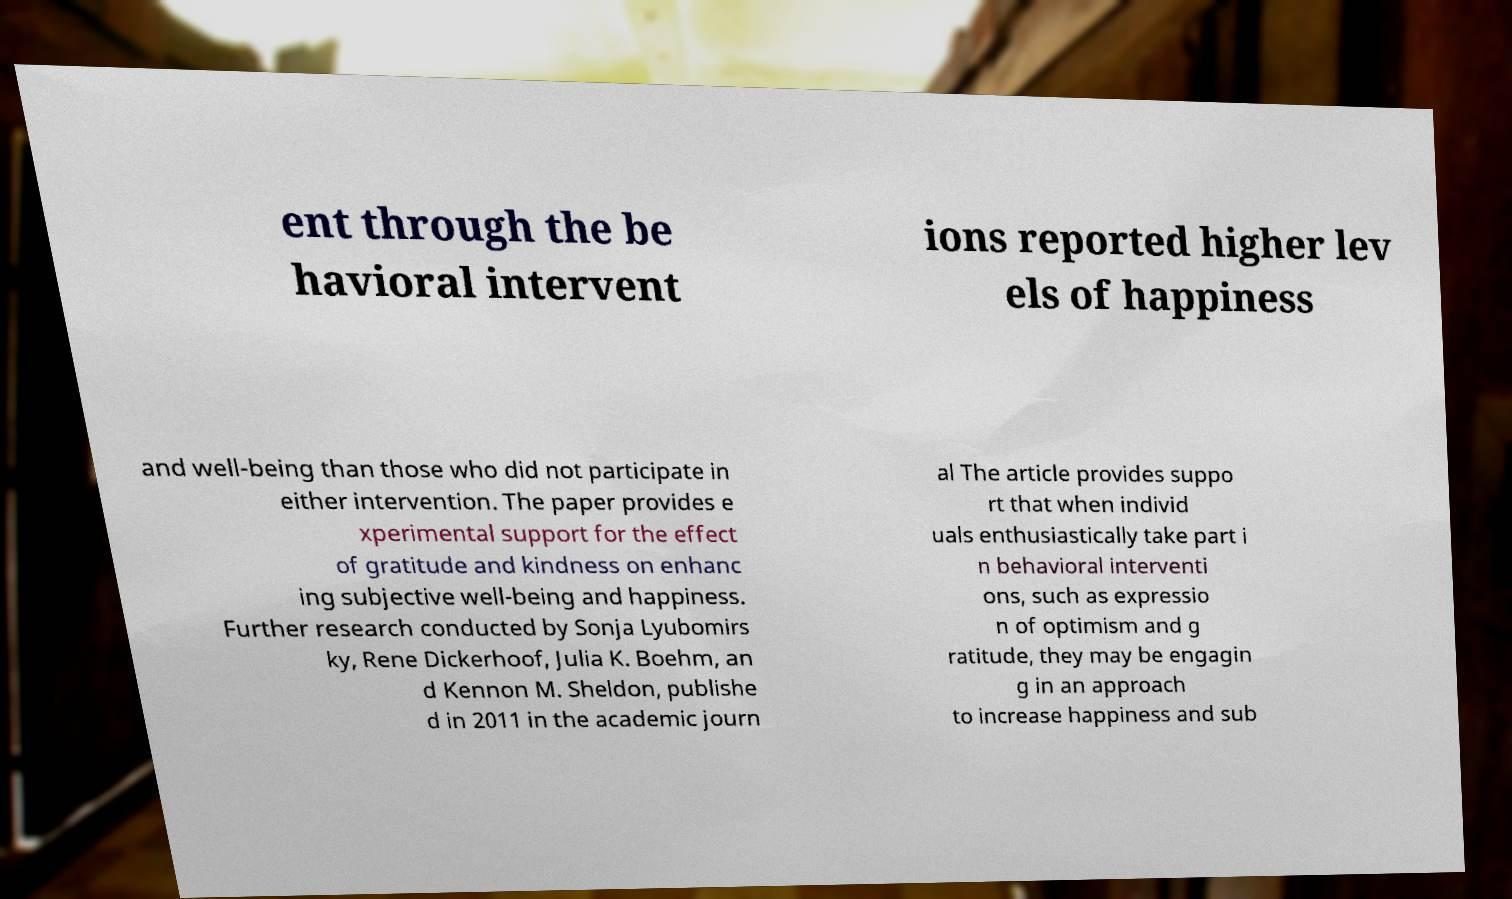Can you read and provide the text displayed in the image?This photo seems to have some interesting text. Can you extract and type it out for me? ent through the be havioral intervent ions reported higher lev els of happiness and well-being than those who did not participate in either intervention. The paper provides e xperimental support for the effect of gratitude and kindness on enhanc ing subjective well-being and happiness. Further research conducted by Sonja Lyubomirs ky, Rene Dickerhoof, Julia K. Boehm, an d Kennon M. Sheldon, publishe d in 2011 in the academic journ al The article provides suppo rt that when individ uals enthusiastically take part i n behavioral interventi ons, such as expressio n of optimism and g ratitude, they may be engagin g in an approach to increase happiness and sub 